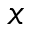<formula> <loc_0><loc_0><loc_500><loc_500>x</formula> 